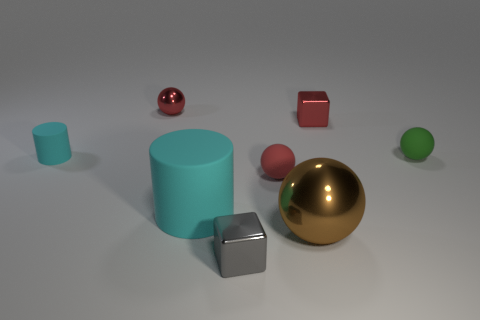Subtract 1 balls. How many balls are left? 3 Add 1 brown metallic objects. How many objects exist? 9 Subtract all cylinders. How many objects are left? 6 Add 4 brown matte balls. How many brown matte balls exist? 4 Subtract 0 yellow balls. How many objects are left? 8 Subtract all small cyan cylinders. Subtract all spheres. How many objects are left? 3 Add 6 red rubber objects. How many red rubber objects are left? 7 